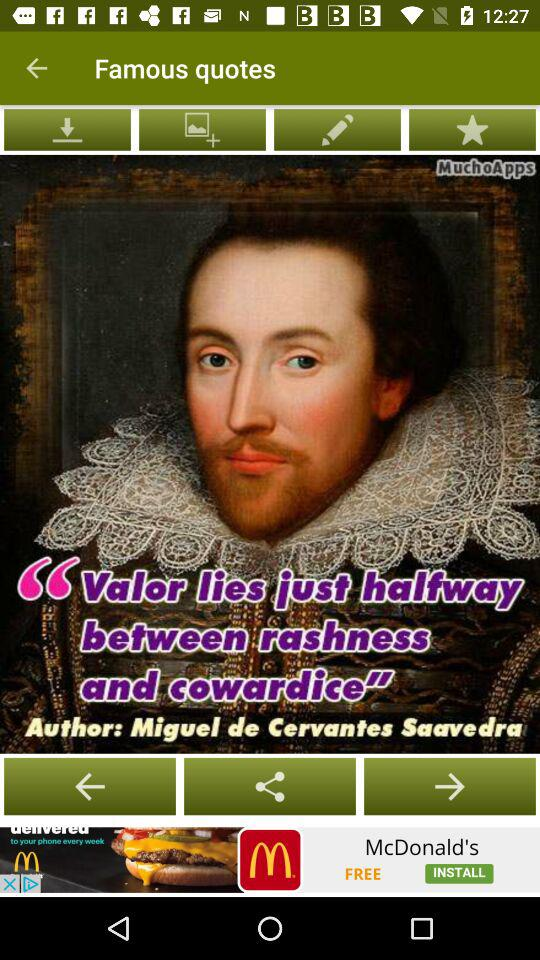Who is the author of the quote? The author of the quote is Miguel de Cervantes Saavedra. 